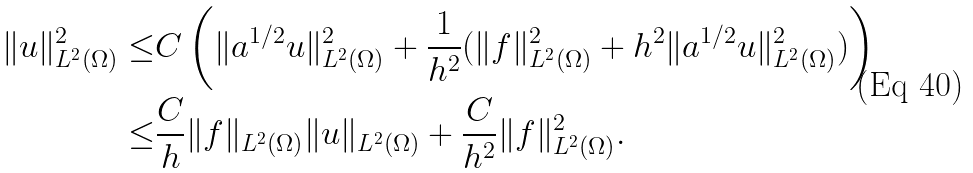<formula> <loc_0><loc_0><loc_500><loc_500>\| u \| _ { L ^ { 2 } ( \Omega ) } ^ { 2 } \leq & C \left ( \| a ^ { 1 / 2 } u \| _ { L ^ { 2 } ( \Omega ) } ^ { 2 } + \frac { 1 } { h ^ { 2 } } ( \| f \| _ { L ^ { 2 } ( \Omega ) } ^ { 2 } + h ^ { 2 } \| a ^ { 1 / 2 } u \| _ { L ^ { 2 } ( \Omega ) } ^ { 2 } ) \right ) \\ \leq & \frac { C } { h } \| f \| _ { L ^ { 2 } ( \Omega ) } \| u \| _ { L ^ { 2 } ( \Omega ) } + \frac { C } { h ^ { 2 } } \| f \| _ { L ^ { 2 } ( \Omega ) } ^ { 2 } .</formula> 